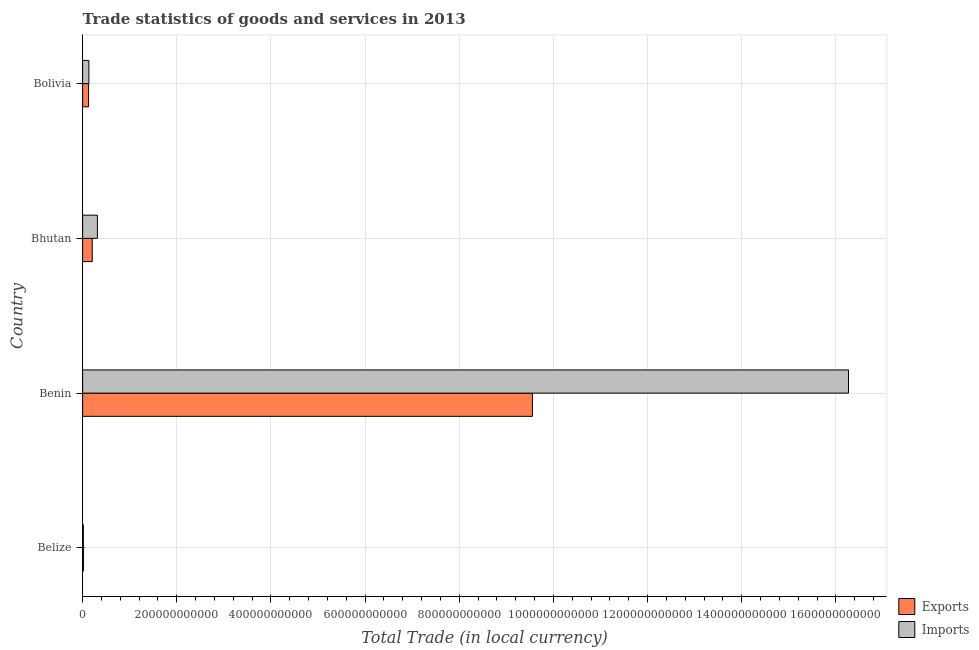Are the number of bars on each tick of the Y-axis equal?
Make the answer very short. Yes. How many bars are there on the 1st tick from the top?
Make the answer very short. 2. How many bars are there on the 3rd tick from the bottom?
Provide a short and direct response. 2. In how many cases, is the number of bars for a given country not equal to the number of legend labels?
Your answer should be compact. 0. What is the export of goods and services in Bolivia?
Ensure brevity in your answer.  1.26e+1. Across all countries, what is the maximum export of goods and services?
Provide a succinct answer. 9.55e+11. Across all countries, what is the minimum export of goods and services?
Offer a very short reply. 1.66e+09. In which country was the export of goods and services maximum?
Keep it short and to the point. Benin. In which country was the export of goods and services minimum?
Ensure brevity in your answer.  Belize. What is the total imports of goods and services in the graph?
Provide a short and direct response. 1.67e+12. What is the difference between the imports of goods and services in Belize and that in Bhutan?
Keep it short and to the point. -2.98e+1. What is the difference between the imports of goods and services in Bhutan and the export of goods and services in Belize?
Provide a short and direct response. 2.97e+1. What is the average imports of goods and services per country?
Provide a short and direct response. 4.18e+11. What is the difference between the imports of goods and services and export of goods and services in Bolivia?
Make the answer very short. 6.05e+08. In how many countries, is the imports of goods and services greater than 1480000000000 LCU?
Provide a succinct answer. 1. What is the ratio of the export of goods and services in Belize to that in Bolivia?
Offer a very short reply. 0.13. Is the difference between the export of goods and services in Belize and Bolivia greater than the difference between the imports of goods and services in Belize and Bolivia?
Your answer should be compact. Yes. What is the difference between the highest and the second highest imports of goods and services?
Ensure brevity in your answer.  1.60e+12. What is the difference between the highest and the lowest imports of goods and services?
Your response must be concise. 1.63e+12. In how many countries, is the export of goods and services greater than the average export of goods and services taken over all countries?
Your answer should be compact. 1. What does the 1st bar from the top in Belize represents?
Give a very brief answer. Imports. What does the 1st bar from the bottom in Bhutan represents?
Give a very brief answer. Exports. Are all the bars in the graph horizontal?
Offer a terse response. Yes. How many countries are there in the graph?
Provide a short and direct response. 4. What is the difference between two consecutive major ticks on the X-axis?
Offer a terse response. 2.00e+11. Does the graph contain any zero values?
Keep it short and to the point. No. How are the legend labels stacked?
Ensure brevity in your answer.  Vertical. What is the title of the graph?
Your answer should be compact. Trade statistics of goods and services in 2013. Does "Highest 20% of population" appear as one of the legend labels in the graph?
Give a very brief answer. No. What is the label or title of the X-axis?
Make the answer very short. Total Trade (in local currency). What is the Total Trade (in local currency) in Exports in Belize?
Your answer should be compact. 1.66e+09. What is the Total Trade (in local currency) of Imports in Belize?
Your answer should be very brief. 1.60e+09. What is the Total Trade (in local currency) of Exports in Benin?
Offer a terse response. 9.55e+11. What is the Total Trade (in local currency) in Imports in Benin?
Your response must be concise. 1.63e+12. What is the Total Trade (in local currency) in Exports in Bhutan?
Offer a terse response. 2.04e+1. What is the Total Trade (in local currency) in Imports in Bhutan?
Offer a very short reply. 3.14e+1. What is the Total Trade (in local currency) in Exports in Bolivia?
Your response must be concise. 1.26e+1. What is the Total Trade (in local currency) in Imports in Bolivia?
Ensure brevity in your answer.  1.32e+1. Across all countries, what is the maximum Total Trade (in local currency) of Exports?
Keep it short and to the point. 9.55e+11. Across all countries, what is the maximum Total Trade (in local currency) of Imports?
Offer a terse response. 1.63e+12. Across all countries, what is the minimum Total Trade (in local currency) in Exports?
Offer a terse response. 1.66e+09. Across all countries, what is the minimum Total Trade (in local currency) in Imports?
Ensure brevity in your answer.  1.60e+09. What is the total Total Trade (in local currency) of Exports in the graph?
Keep it short and to the point. 9.90e+11. What is the total Total Trade (in local currency) of Imports in the graph?
Ensure brevity in your answer.  1.67e+12. What is the difference between the Total Trade (in local currency) of Exports in Belize and that in Benin?
Keep it short and to the point. -9.54e+11. What is the difference between the Total Trade (in local currency) of Imports in Belize and that in Benin?
Ensure brevity in your answer.  -1.63e+12. What is the difference between the Total Trade (in local currency) of Exports in Belize and that in Bhutan?
Make the answer very short. -1.87e+1. What is the difference between the Total Trade (in local currency) of Imports in Belize and that in Bhutan?
Your answer should be very brief. -2.98e+1. What is the difference between the Total Trade (in local currency) of Exports in Belize and that in Bolivia?
Ensure brevity in your answer.  -1.10e+1. What is the difference between the Total Trade (in local currency) in Imports in Belize and that in Bolivia?
Provide a short and direct response. -1.17e+1. What is the difference between the Total Trade (in local currency) in Exports in Benin and that in Bhutan?
Offer a very short reply. 9.35e+11. What is the difference between the Total Trade (in local currency) of Imports in Benin and that in Bhutan?
Make the answer very short. 1.60e+12. What is the difference between the Total Trade (in local currency) of Exports in Benin and that in Bolivia?
Your response must be concise. 9.43e+11. What is the difference between the Total Trade (in local currency) of Imports in Benin and that in Bolivia?
Your response must be concise. 1.61e+12. What is the difference between the Total Trade (in local currency) in Exports in Bhutan and that in Bolivia?
Give a very brief answer. 7.75e+09. What is the difference between the Total Trade (in local currency) in Imports in Bhutan and that in Bolivia?
Your response must be concise. 1.81e+1. What is the difference between the Total Trade (in local currency) of Exports in Belize and the Total Trade (in local currency) of Imports in Benin?
Provide a succinct answer. -1.63e+12. What is the difference between the Total Trade (in local currency) in Exports in Belize and the Total Trade (in local currency) in Imports in Bhutan?
Ensure brevity in your answer.  -2.97e+1. What is the difference between the Total Trade (in local currency) of Exports in Belize and the Total Trade (in local currency) of Imports in Bolivia?
Your answer should be compact. -1.16e+1. What is the difference between the Total Trade (in local currency) in Exports in Benin and the Total Trade (in local currency) in Imports in Bhutan?
Make the answer very short. 9.24e+11. What is the difference between the Total Trade (in local currency) of Exports in Benin and the Total Trade (in local currency) of Imports in Bolivia?
Keep it short and to the point. 9.42e+11. What is the difference between the Total Trade (in local currency) of Exports in Bhutan and the Total Trade (in local currency) of Imports in Bolivia?
Your answer should be compact. 7.15e+09. What is the average Total Trade (in local currency) in Exports per country?
Give a very brief answer. 2.48e+11. What is the average Total Trade (in local currency) in Imports per country?
Make the answer very short. 4.18e+11. What is the difference between the Total Trade (in local currency) in Exports and Total Trade (in local currency) in Imports in Belize?
Give a very brief answer. 6.94e+07. What is the difference between the Total Trade (in local currency) of Exports and Total Trade (in local currency) of Imports in Benin?
Make the answer very short. -6.71e+11. What is the difference between the Total Trade (in local currency) of Exports and Total Trade (in local currency) of Imports in Bhutan?
Your answer should be compact. -1.10e+1. What is the difference between the Total Trade (in local currency) in Exports and Total Trade (in local currency) in Imports in Bolivia?
Your answer should be very brief. -6.05e+08. What is the ratio of the Total Trade (in local currency) in Exports in Belize to that in Benin?
Ensure brevity in your answer.  0. What is the ratio of the Total Trade (in local currency) in Exports in Belize to that in Bhutan?
Provide a short and direct response. 0.08. What is the ratio of the Total Trade (in local currency) in Imports in Belize to that in Bhutan?
Offer a very short reply. 0.05. What is the ratio of the Total Trade (in local currency) in Exports in Belize to that in Bolivia?
Give a very brief answer. 0.13. What is the ratio of the Total Trade (in local currency) of Imports in Belize to that in Bolivia?
Your answer should be compact. 0.12. What is the ratio of the Total Trade (in local currency) in Exports in Benin to that in Bhutan?
Offer a very short reply. 46.85. What is the ratio of the Total Trade (in local currency) of Imports in Benin to that in Bhutan?
Provide a succinct answer. 51.83. What is the ratio of the Total Trade (in local currency) of Exports in Benin to that in Bolivia?
Keep it short and to the point. 75.57. What is the ratio of the Total Trade (in local currency) of Imports in Benin to that in Bolivia?
Give a very brief answer. 122.81. What is the ratio of the Total Trade (in local currency) of Exports in Bhutan to that in Bolivia?
Give a very brief answer. 1.61. What is the ratio of the Total Trade (in local currency) in Imports in Bhutan to that in Bolivia?
Your response must be concise. 2.37. What is the difference between the highest and the second highest Total Trade (in local currency) in Exports?
Your answer should be very brief. 9.35e+11. What is the difference between the highest and the second highest Total Trade (in local currency) of Imports?
Your answer should be compact. 1.60e+12. What is the difference between the highest and the lowest Total Trade (in local currency) in Exports?
Make the answer very short. 9.54e+11. What is the difference between the highest and the lowest Total Trade (in local currency) of Imports?
Offer a very short reply. 1.63e+12. 